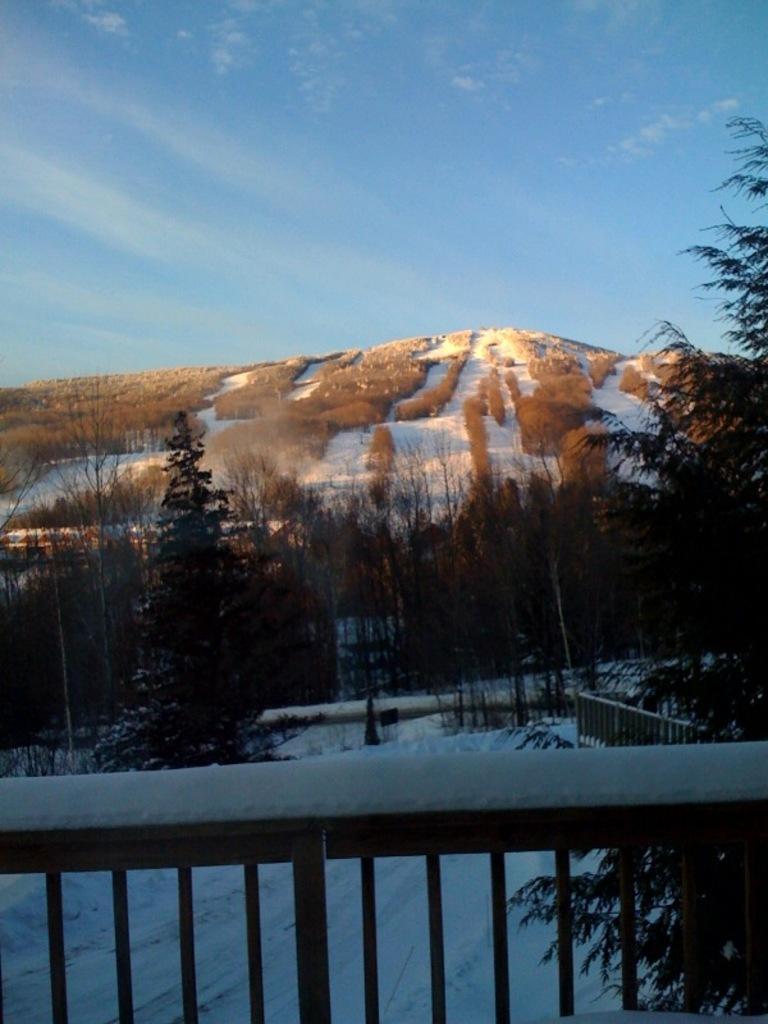How would you summarize this image in a sentence or two? In this image, we can see railings, snow and trees. In the background, we can see snow, hill and the sky. 